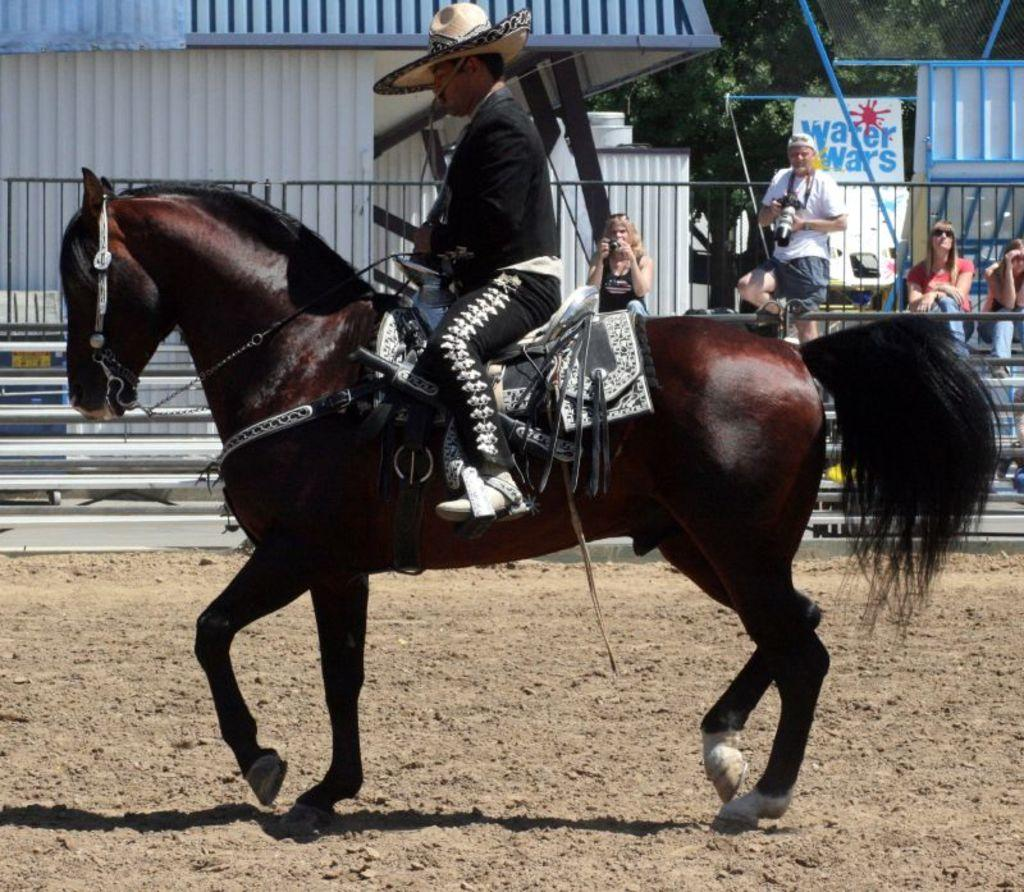What is the main subject of the image? There is a person riding a horse in the image. What is the horse's current state? The horse is on the ground. What can be observed about the people in the background? There are people sitting and standing in the background of the image, and some of them are taking pictures. What type of wash is the horse experiencing in the image? There is no indication in the image that the horse is experiencing any type of wash. 